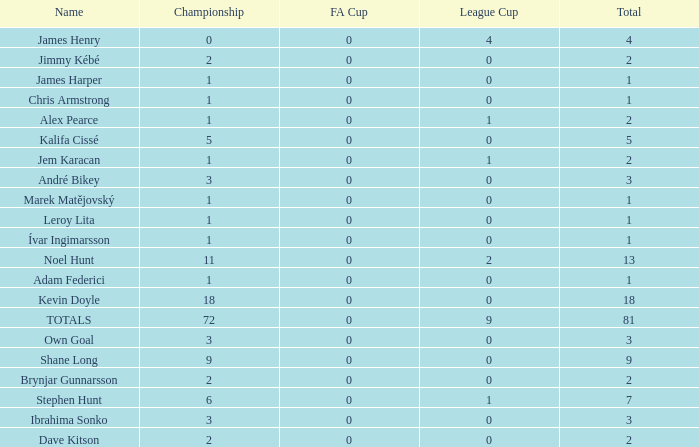What is the total championships of James Henry that has a league cup more than 1? 0.0. 